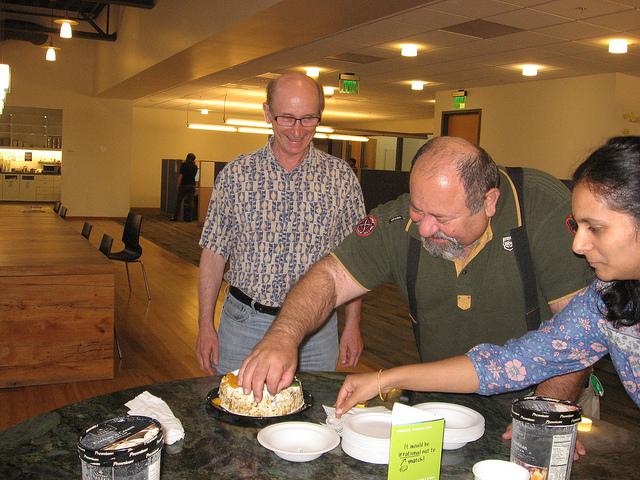How many ice cream containers are there?
Give a very brief answer. 2. Which room is this?
Keep it brief. Lobby. What is the man doing with his hand?
Write a very short answer. Touching cake. What kind of flooring is there?
Give a very brief answer. Wood. 